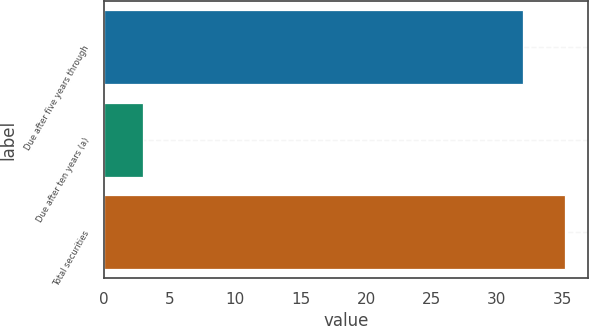Convert chart to OTSL. <chart><loc_0><loc_0><loc_500><loc_500><bar_chart><fcel>Due after five years through<fcel>Due after ten years (a)<fcel>Total securities<nl><fcel>32<fcel>3<fcel>35.2<nl></chart> 